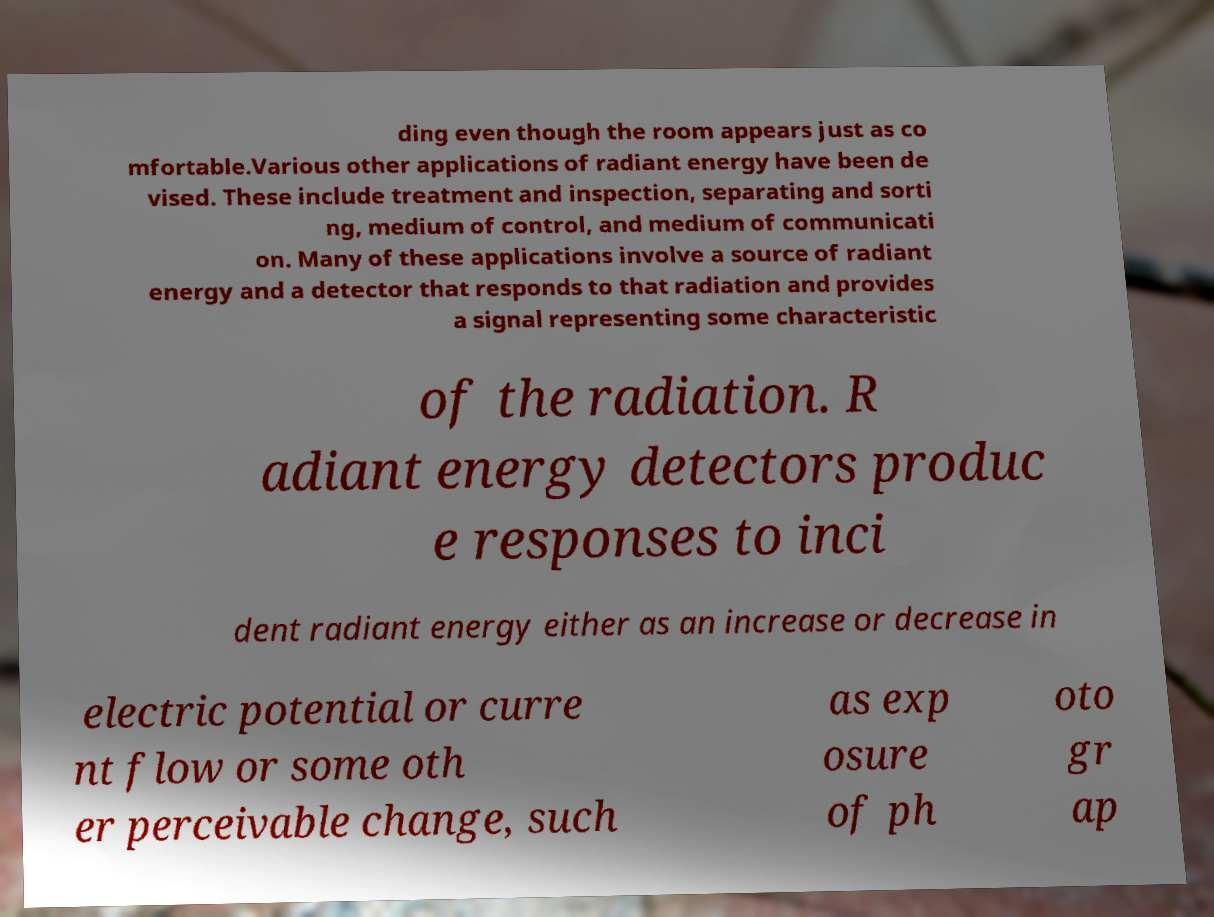For documentation purposes, I need the text within this image transcribed. Could you provide that? ding even though the room appears just as co mfortable.Various other applications of radiant energy have been de vised. These include treatment and inspection, separating and sorti ng, medium of control, and medium of communicati on. Many of these applications involve a source of radiant energy and a detector that responds to that radiation and provides a signal representing some characteristic of the radiation. R adiant energy detectors produc e responses to inci dent radiant energy either as an increase or decrease in electric potential or curre nt flow or some oth er perceivable change, such as exp osure of ph oto gr ap 